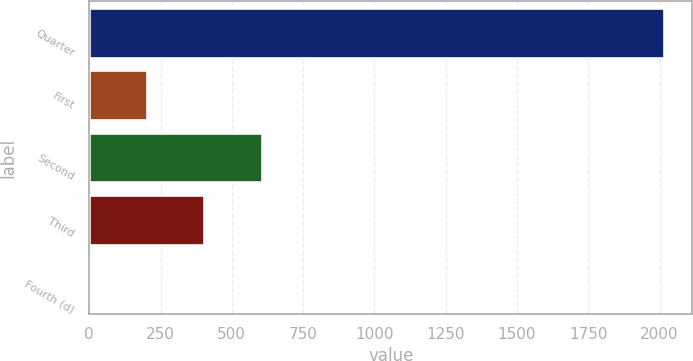Convert chart. <chart><loc_0><loc_0><loc_500><loc_500><bar_chart><fcel>Quarter<fcel>First<fcel>Second<fcel>Third<fcel>Fourth (d)<nl><fcel>2014<fcel>202.39<fcel>604.97<fcel>403.68<fcel>1.1<nl></chart> 